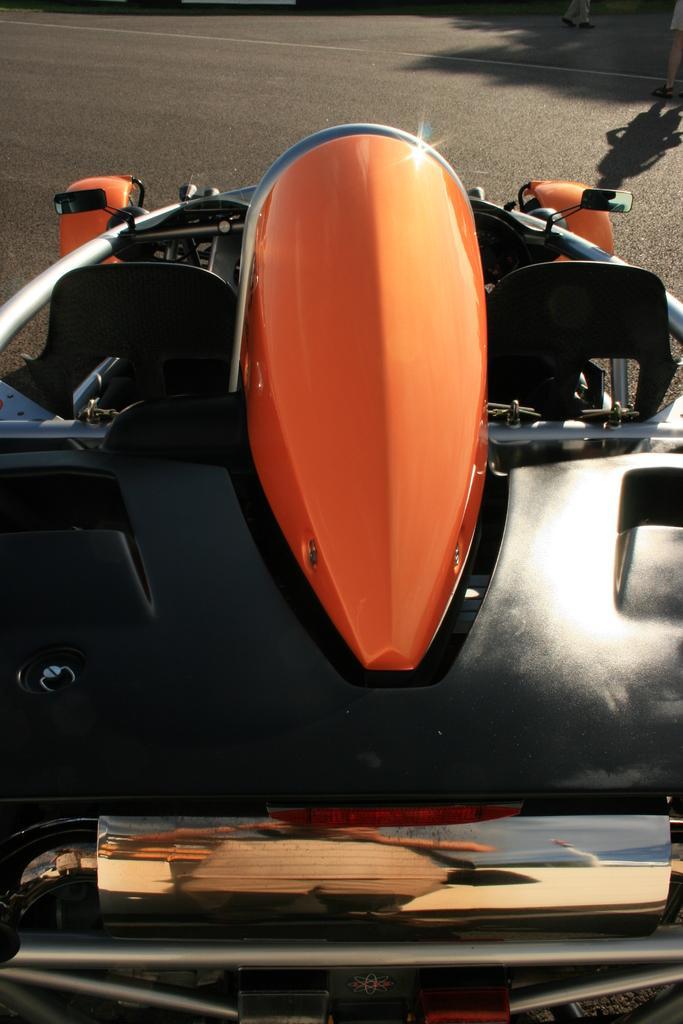How would you summarize this image in a sentence or two? In the center of the image, we can see a vehicle on the road. 